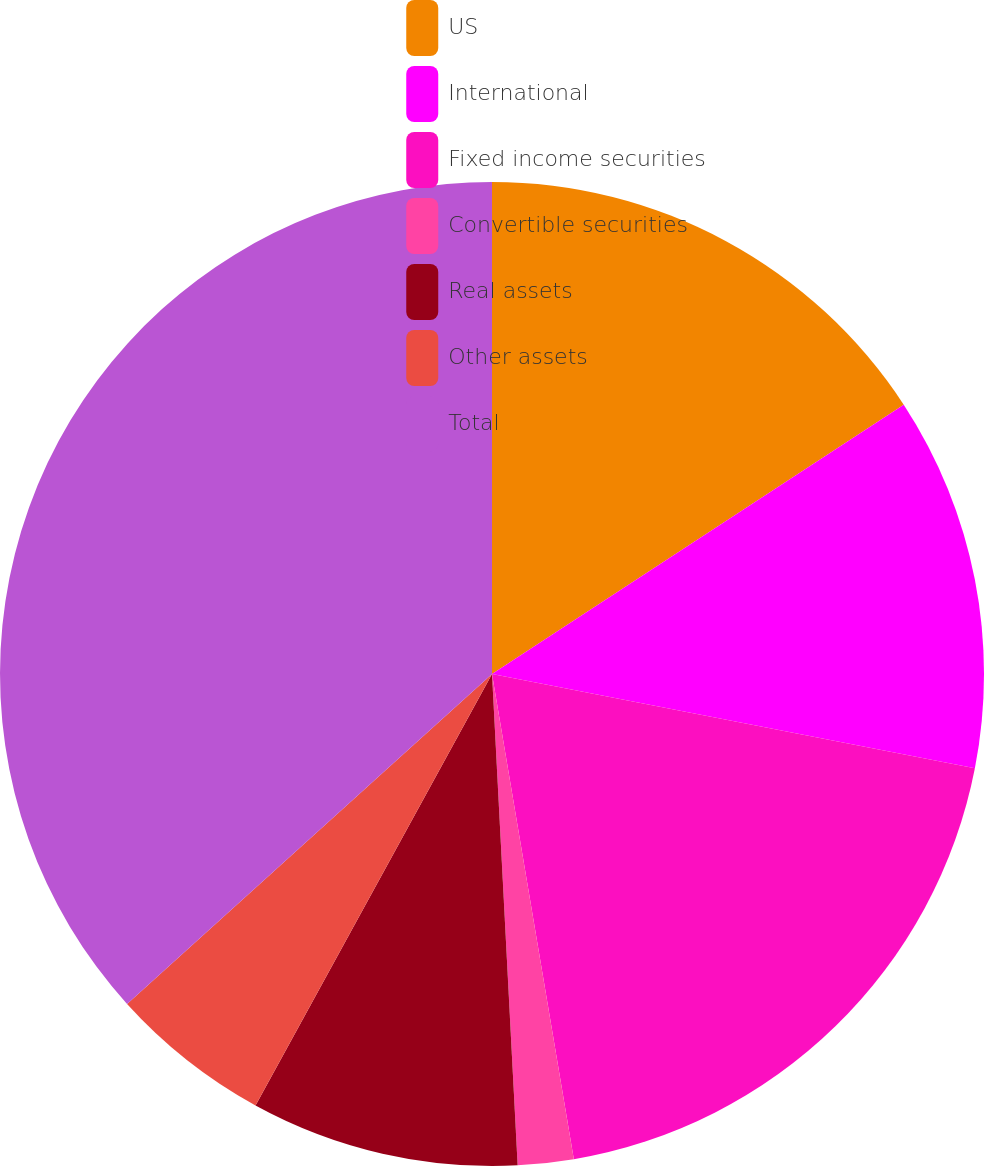Convert chart. <chart><loc_0><loc_0><loc_500><loc_500><pie_chart><fcel>US<fcel>International<fcel>Fixed income securities<fcel>Convertible securities<fcel>Real assets<fcel>Other assets<fcel>Total<nl><fcel>15.78%<fcel>12.29%<fcel>19.27%<fcel>1.83%<fcel>8.81%<fcel>5.32%<fcel>36.7%<nl></chart> 